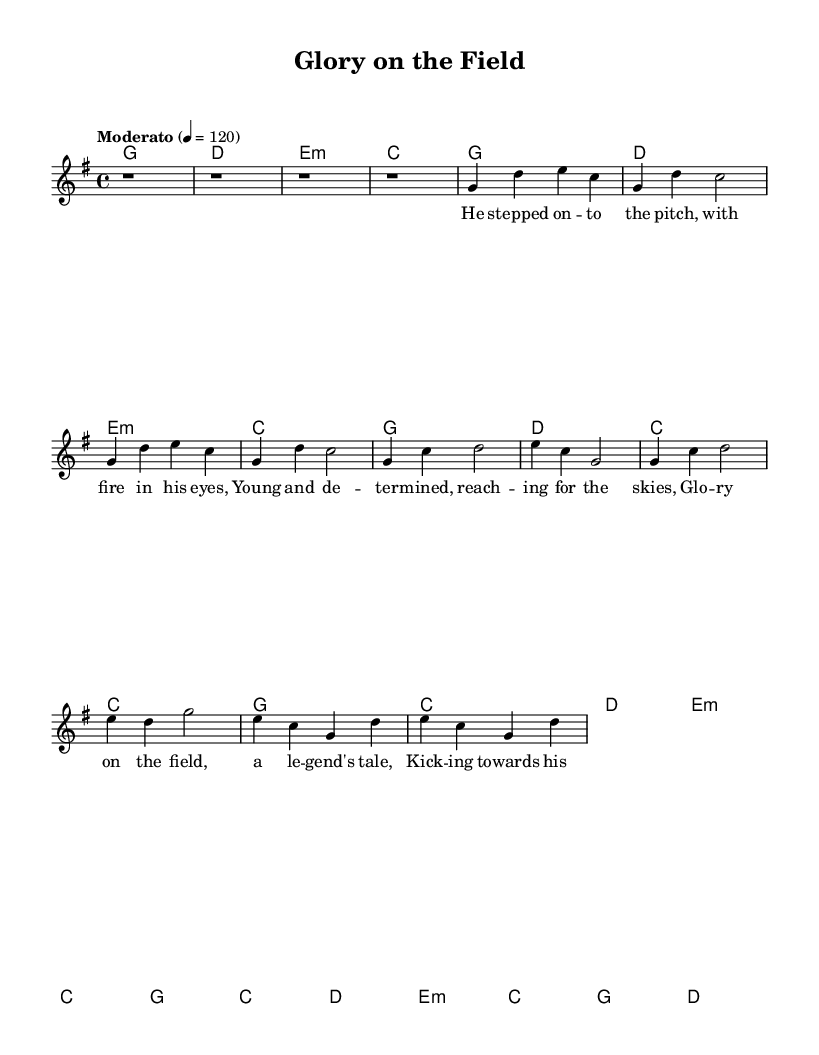What is the key signature of this music? The key signature is determined by looking at the key indicated in the global section. It is in G major, which has one sharp (F#).
Answer: G major What is the time signature of the music? The time signature is indicated in the global section of the sheet music. It shows a 4/4 time signature, meaning there are four beats in each measure.
Answer: 4/4 What is the tempo marking for this piece? The tempo marking can be found in the global section, stating "Moderato" with a metronome marking of 120, indicating a moderate speed.
Answer: Moderato How many measures are in the chorus section? By examining the structure presented in the melody part, the chorus consists of four measures as indicated by the notation.
Answer: 4 Which chord is played in the bridge section? The chord progression indicates that E minor is used in the bridge. Observing the harmonies section, it confirms that the first chord in the bridge is E minor.
Answer: E minor What lyrical theme is presented in the verse? The verse discusses a player entering the pitch with determination and ambition, which is a common theme in sports songs celebrating athletes.
Answer: Determination What is the overall impact of the title "Glory on the Field"? The title suggests an uplifting and triumphant celebration of sports achievements, reflecting the subject of sports legends and their stories.
Answer: Triumph 